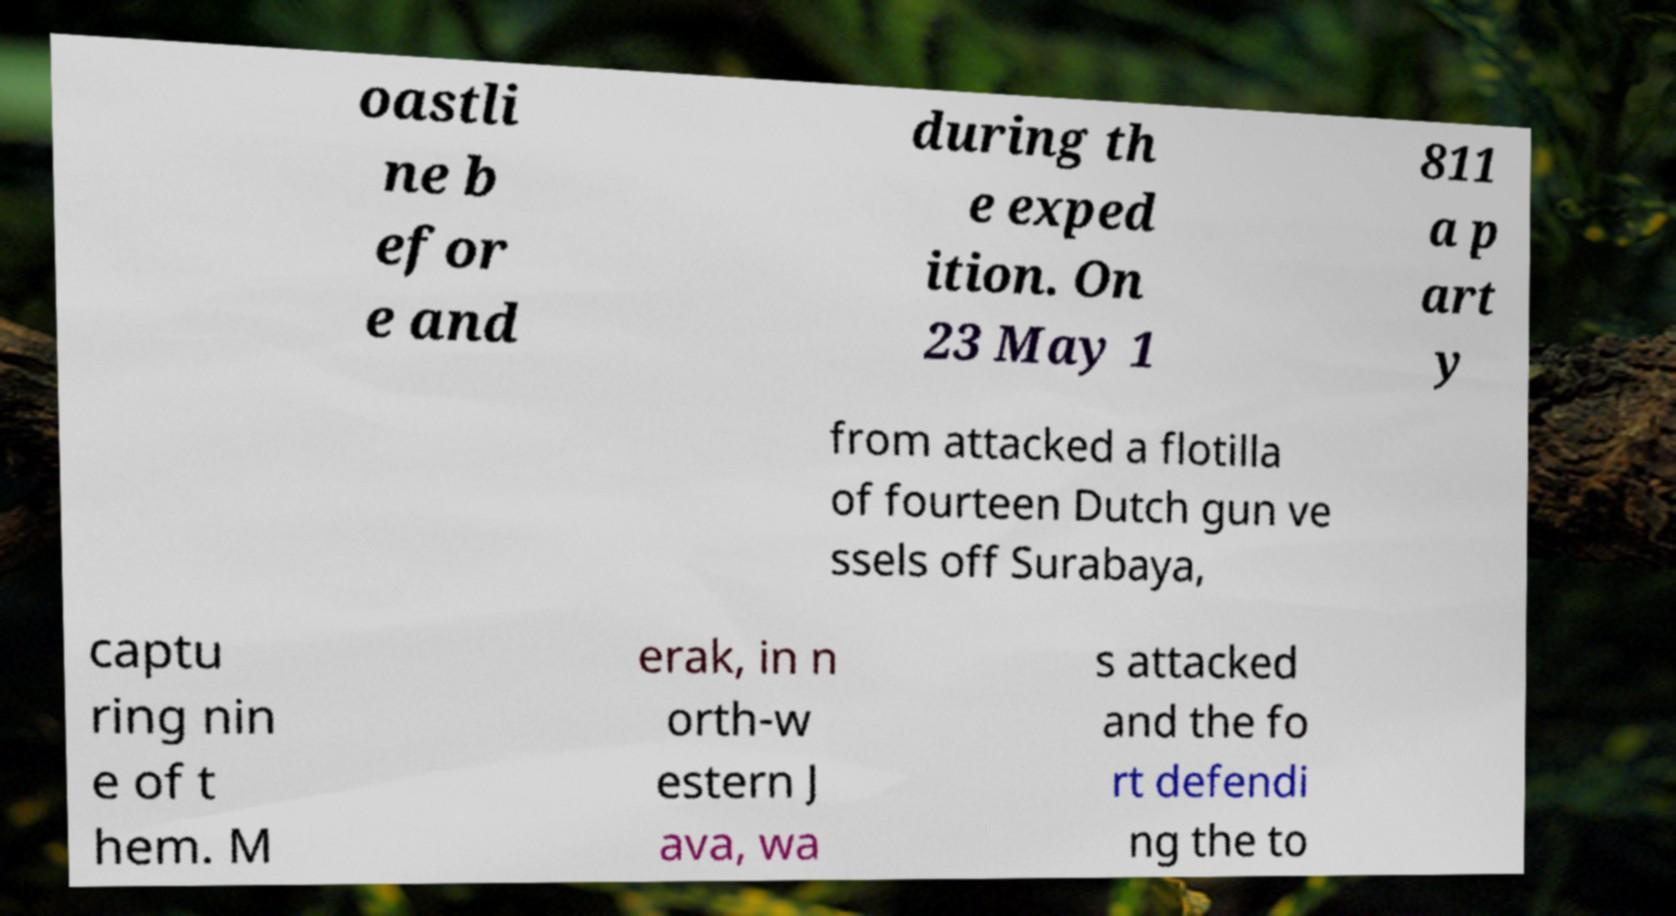Could you assist in decoding the text presented in this image and type it out clearly? oastli ne b efor e and during th e exped ition. On 23 May 1 811 a p art y from attacked a flotilla of fourteen Dutch gun ve ssels off Surabaya, captu ring nin e of t hem. M erak, in n orth-w estern J ava, wa s attacked and the fo rt defendi ng the to 